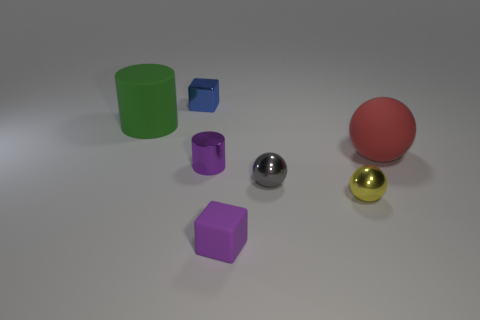What size is the object that is the same color as the tiny matte cube?
Offer a terse response. Small. There is a large object that is right of the blue object; does it have the same shape as the tiny blue metallic thing?
Give a very brief answer. No. Are there more cylinders that are on the right side of the purple rubber thing than small rubber objects that are behind the gray object?
Your answer should be very brief. No. There is a cube that is in front of the tiny gray object; what number of tiny blue metal blocks are to the left of it?
Provide a succinct answer. 1. What is the material of the block that is the same color as the tiny cylinder?
Offer a very short reply. Rubber. What number of other objects are the same color as the small shiny cylinder?
Your response must be concise. 1. What is the color of the block that is in front of the large rubber object right of the small blue metallic thing?
Provide a short and direct response. Purple. Are there any tiny balls that have the same color as the big matte cylinder?
Your answer should be very brief. No. What number of rubber things are either tiny cyan cylinders or tiny cylinders?
Ensure brevity in your answer.  0. Are there any red balls that have the same material as the tiny gray sphere?
Provide a short and direct response. No. 